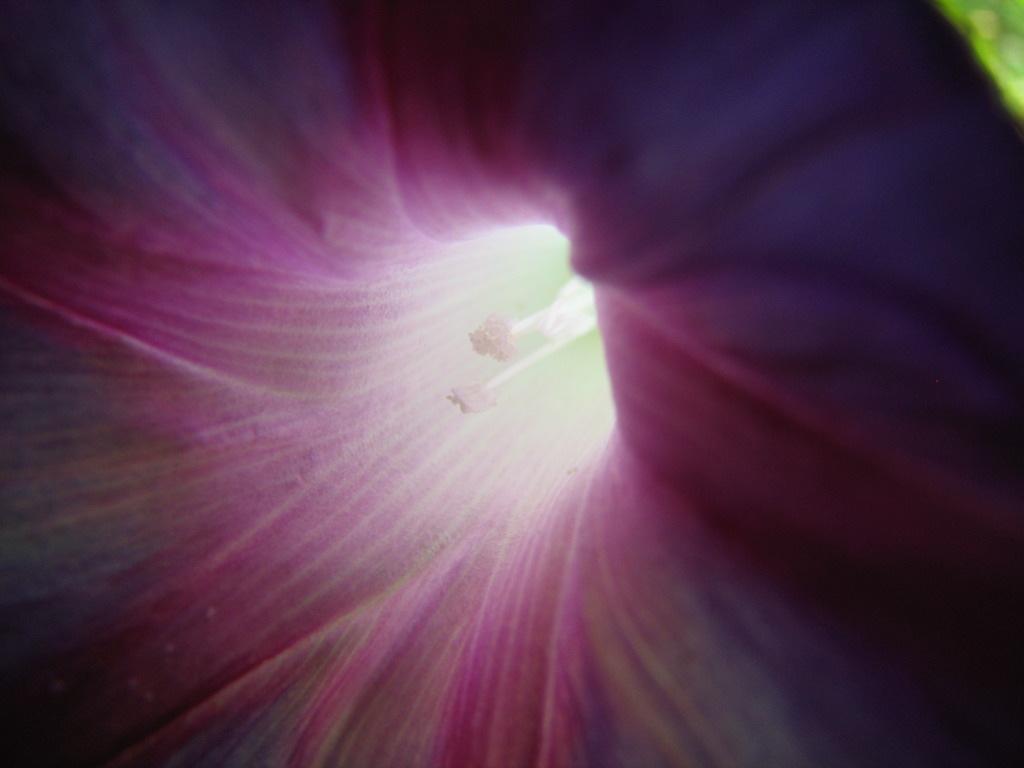Could you give a brief overview of what you see in this image? In this image we can see the inside view of a flower. 